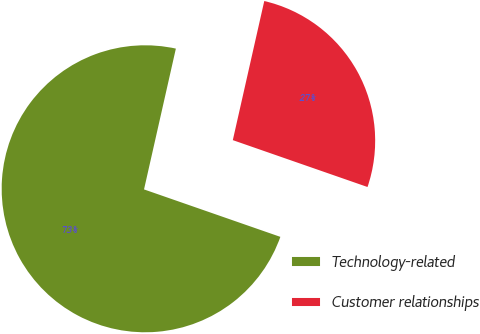Convert chart to OTSL. <chart><loc_0><loc_0><loc_500><loc_500><pie_chart><fcel>Technology-related<fcel>Customer relationships<nl><fcel>73.21%<fcel>26.79%<nl></chart> 